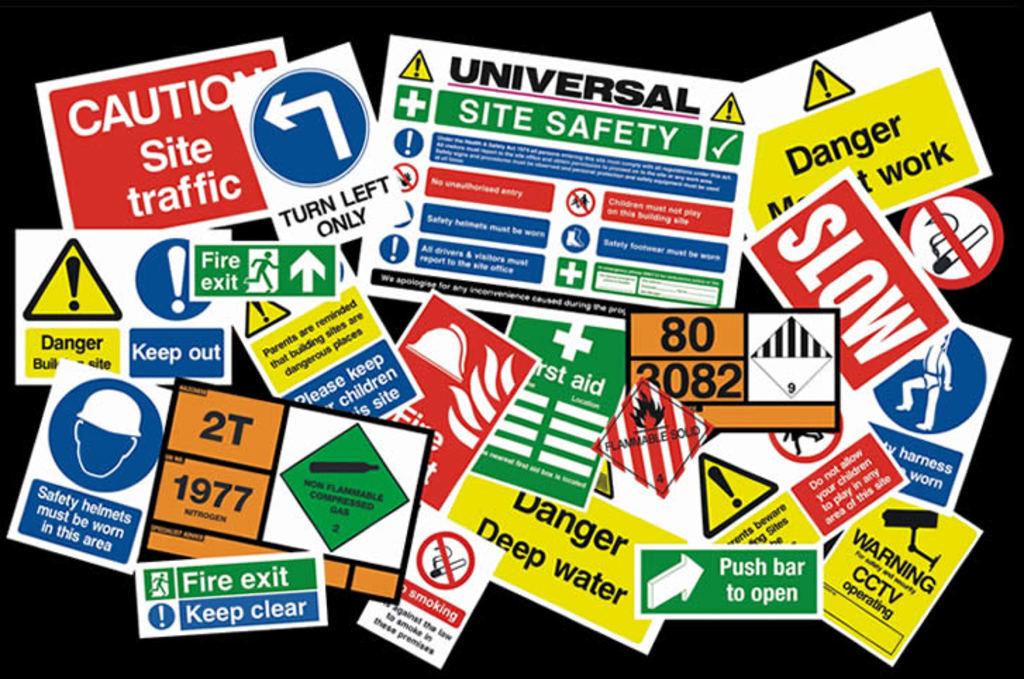Are all the sticker danger stickers ?
Make the answer very short. No. What is the top left sign cautioning about?
Your answer should be compact. Site traffic. 